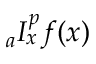<formula> <loc_0><loc_0><loc_500><loc_500>{ } _ { a } I _ { x } ^ { p } f ( x )</formula> 